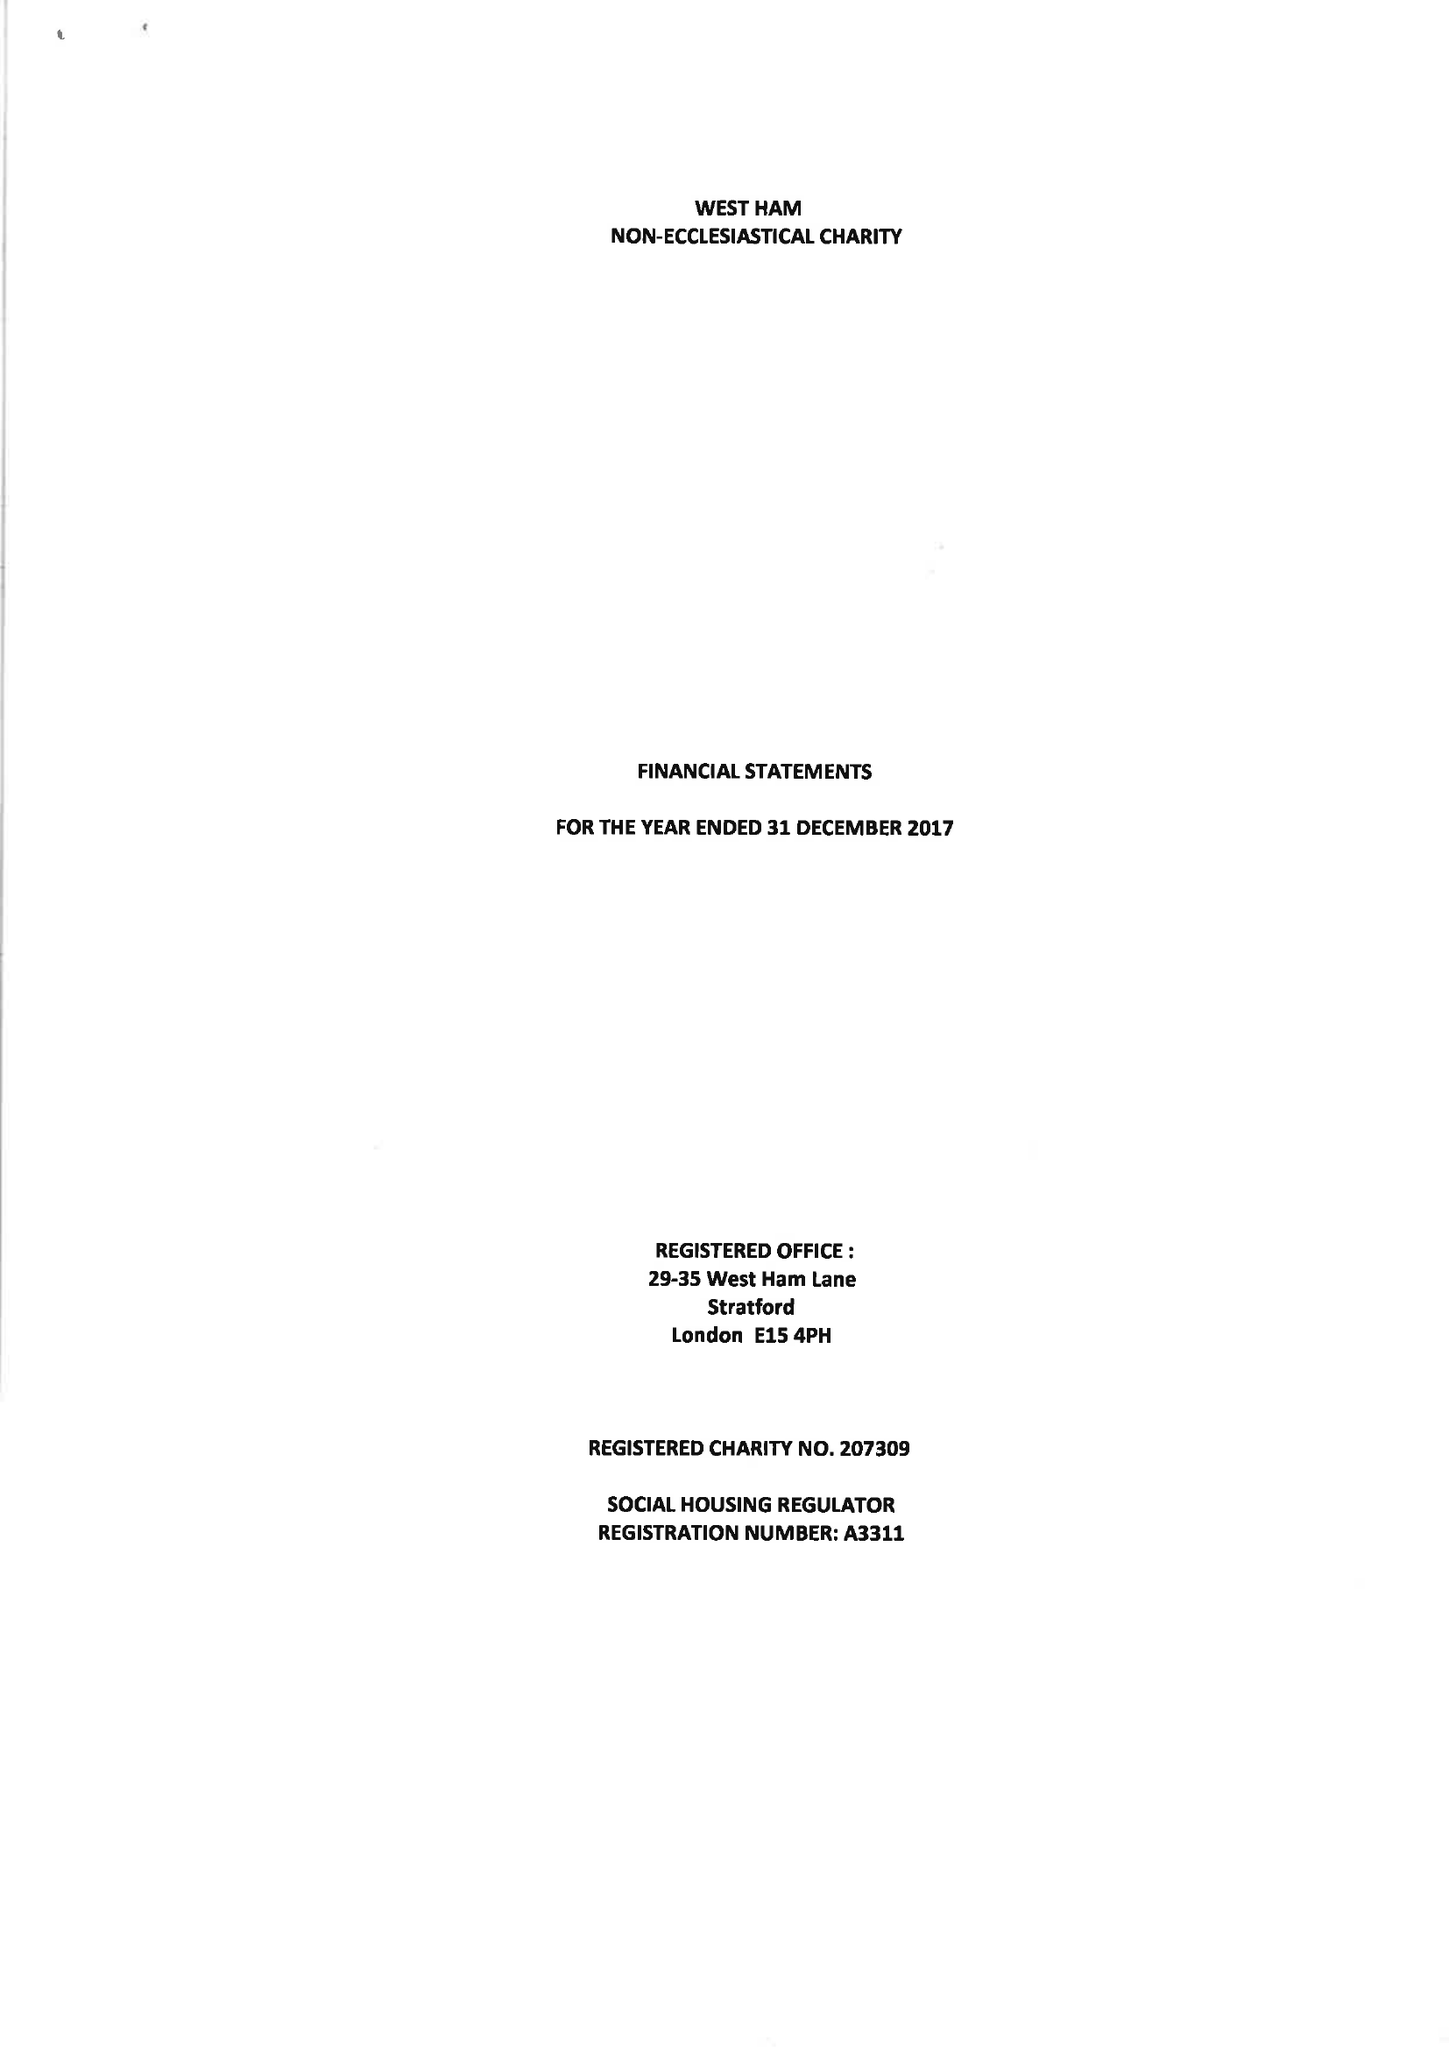What is the value for the income_annually_in_british_pounds?
Answer the question using a single word or phrase. 98766.00 